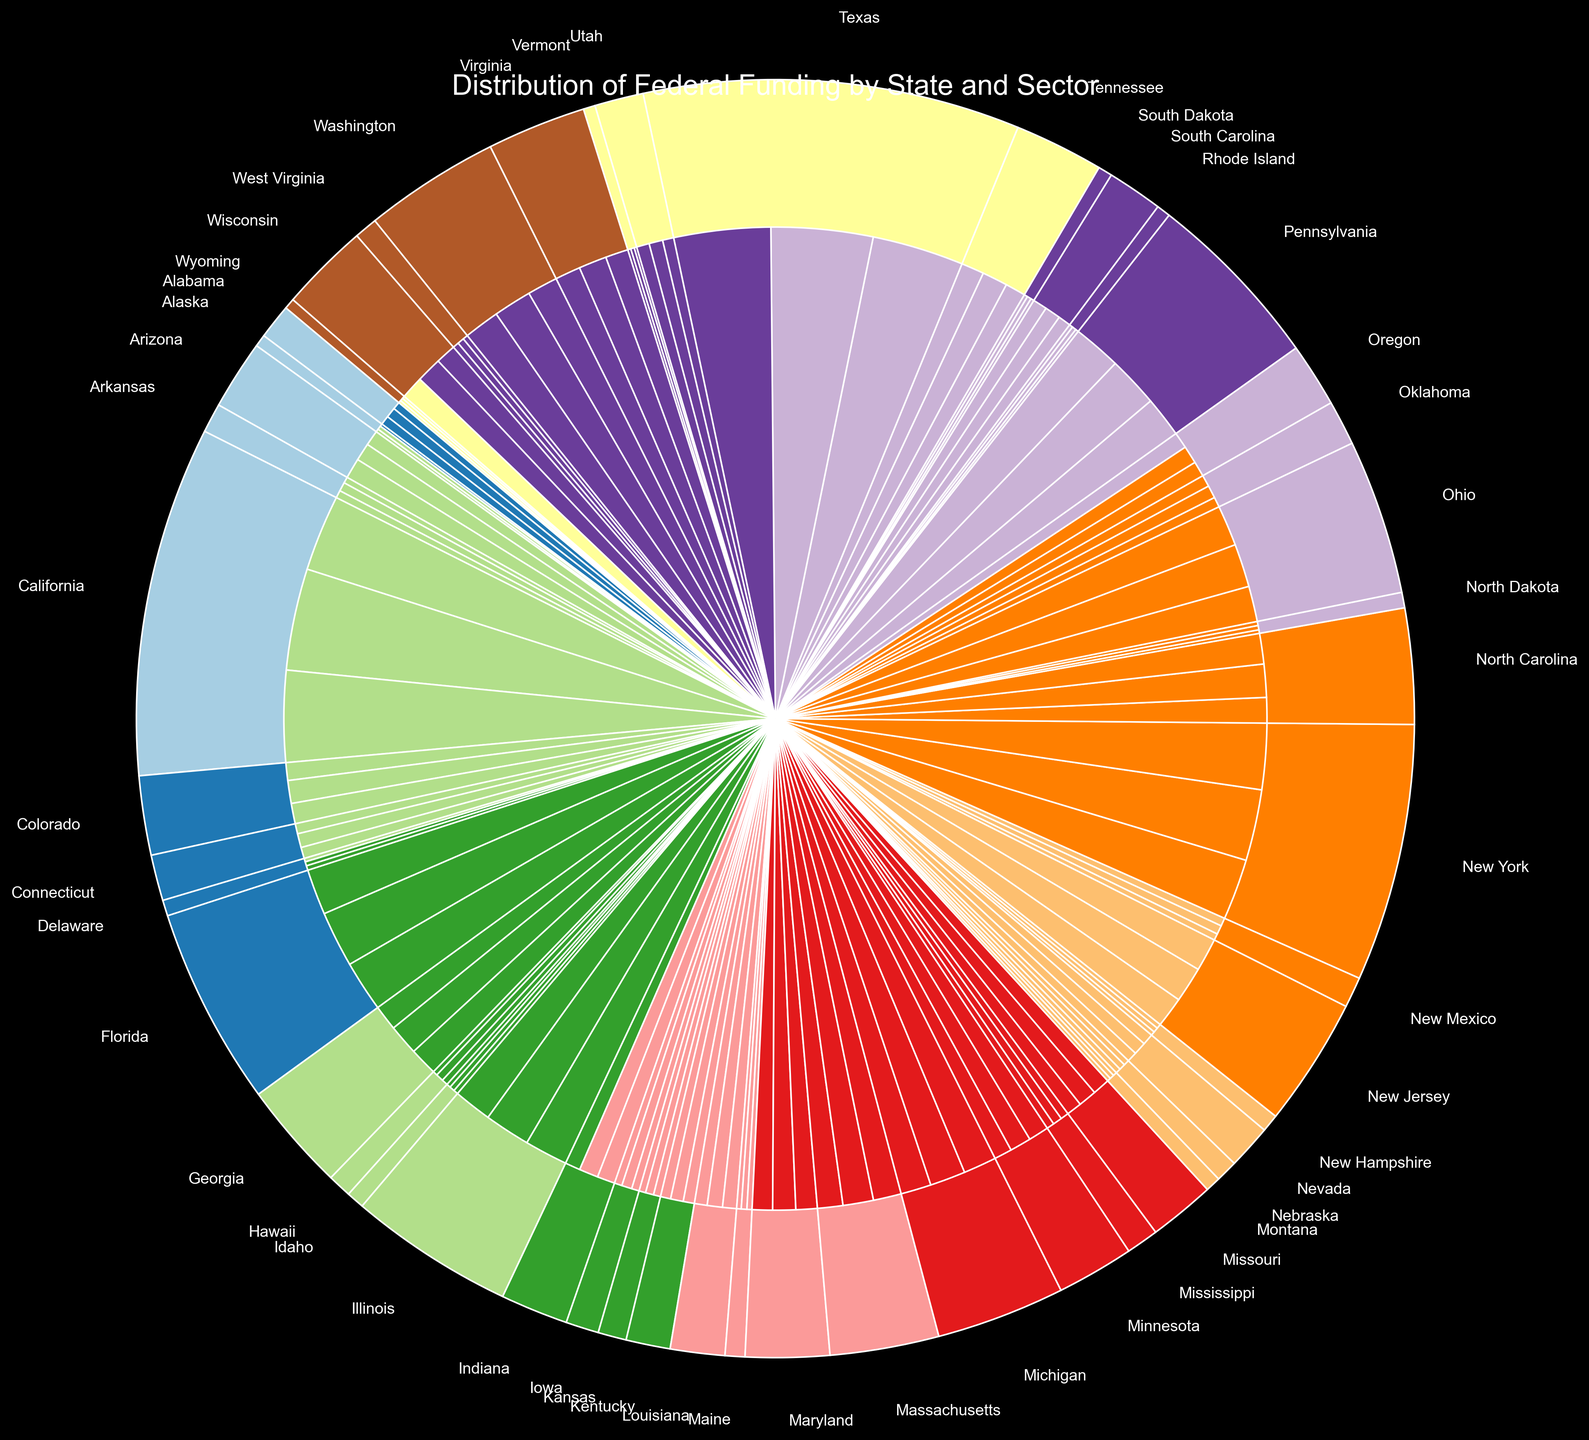What's the total amount of federal funding allocated to California? Sum the amounts allocated to California for each sector (Education, Healthcare, Infrastructure). California's funding amounts are $1,500,000,000 for Education, $2,000,000,000 for Healthcare, and $1,800,000,000 for Infrastructure. Thus, the total is $1,500,000,000 + $2,000,000,000 + $1,800,000,000 = $5,300,000,000.
Answer: $5,300,000,000 Which state receives the highest total federal funding? Compare the total amounts of federal funding allocated to each state. California receives the highest total with $5,300,000,000.
Answer: California How does the federal funding for Healthcare in Texas compare to that in New York? Compare the Healthcare funding amounts for Texas and New York. Texas receives $2,000,000,000, and New York receives $1,400,000,000. Texas receives more Healthcare funding than New York by $600,000,000.
Answer: Texas receives $600,000,000 more What sector receives the least amount of funding in North Dakota? Compare the amounts for each sector in North Dakota. For North Dakota: Education receives $70,000,000, Healthcare receives $85,000,000, and Infrastructure receives $80,000,000. Education receives the least amount of funding.
Answer: Education What's the average amount of federal funding allocated per state for Infrastructure? Sum the total Infrastructure funding and divide by the number of states. The total Infrastructure funding is $22,500,000,000, and there are 50 states. So, the average is $22,500,000,000 / 50 = $450,000,000.
Answer: $450,000,000 What proportion of Alabama’s total federal funding is allocated to Healthcare? First, calculate Alabama’s total federal funding: $150,000,000 for Education, $200,000,000 for Healthcare, and $180,000,000 for Infrastructure. So, the total is $150,000,000 + $200,000,000 + $180,000,000 = $530,000,000. The proportion for Healthcare is $200,000,000 / $530,000,000.
Answer: 37.74% Is the funding allocated to Education in Wyoming higher or lower than the funding allocated to Healthcare in Rhode Island? Compare the funding amounts: Wyoming’s Education funding is $50,000,000, and Rhode Island’s Healthcare funding is $80,000,000. Wyoming’s Education funding is lower.
Answer: Lower By how much does the federal funding for Infrastructure in Ohio exceed that in Mississippi? Compare the Infrastructure funding amount in Ohio and Mississippi. Ohio’s Infrastructure funding is $800,000,000, and Mississippi’s Infrastructure funding is $160,000,000. The difference is $800,000,000 - $160,000,000 = $640,000,000.
Answer: $640,000,000 Which sector in Florida receives the highest amount of federal funding, and what is the amount? Compare the funding amounts in Florida for each sector. For Florida: Education receives $900,000,000, Healthcare receives $1,100,000,000, and Infrastructure receives $1,000,000,000. Healthcare receives the highest amount, which is $1,100,000,000.
Answer: Healthcare, $1,100,000,000 If you sum the total federal funding for Education in Arizona and Indiana, what is the result? The federal funding for Education in Arizona is $300,000,000, and for Indiana, it is $300,000,000. Summing these amounts: $300,000,000 + $300,000,000 = $600,000,000.
Answer: $600,000,000 